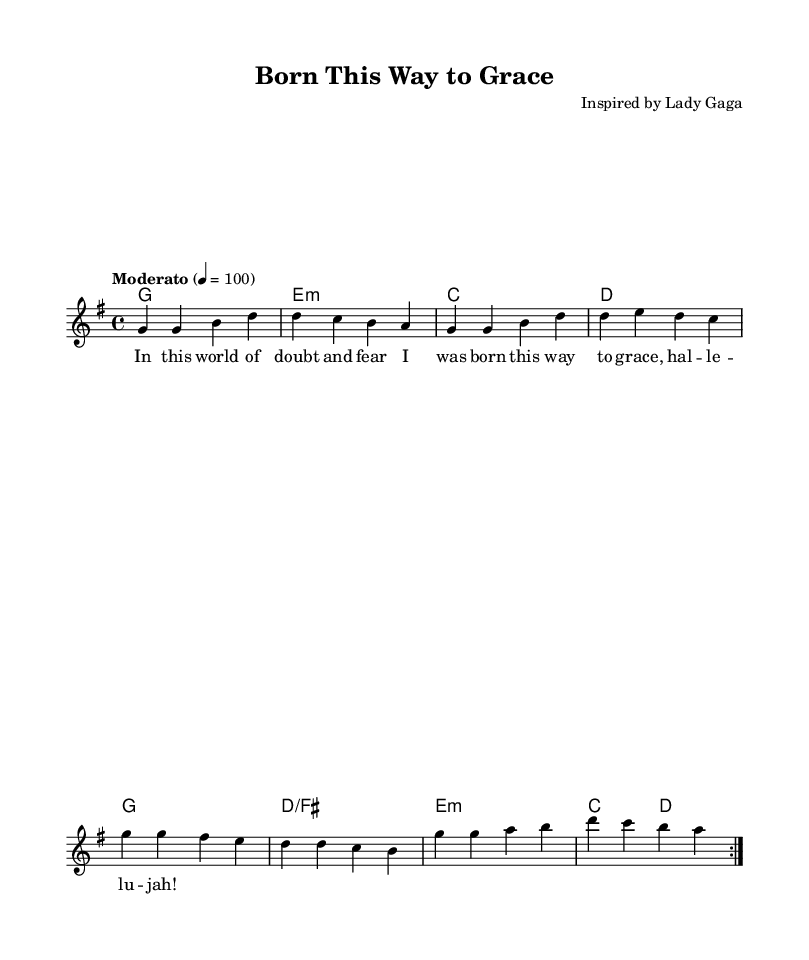What is the tempo marking for this music? The tempo marking is indicated as "Moderato" with a metronome marking of 100 beats per minute. This indicates a moderate pace for the piece.
Answer: Moderato 100 What is the key signature of this music? The key signature is G major, indicated by one sharp (F#), which is visible at the beginning of the staff.
Answer: G major How many measures are in the first section of the music? The first section repeats twice with four measures each time, resulting in a total of eight measures.
Answer: Eight measures What is the time signature of this music? The time signature shown at the beginning is 4/4, which means there are four beats per measure and the quarter note gets one beat.
Answer: 4/4 What is the lyric refrain that follows the verse? The words "ho -- le -- lu -- jah!" are included in the lyrics' refrain, providing a significant expressiveness typical of religious music.
Answer: ho -- le -- lu -- jah! How does the harmonic structure support the melody in the first four measures? The first four measures contain a simple harmonic progression: G to E minor to C to D, which provides a stable foundation and supports the uplifting nature of the melody.
Answer: G, E minor, C, D 